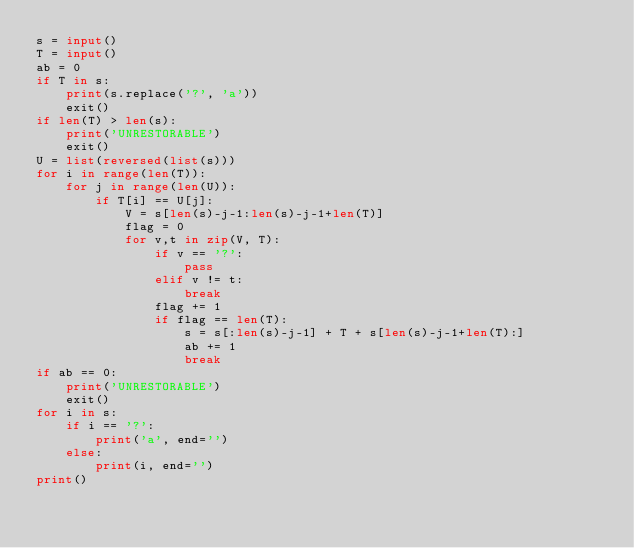Convert code to text. <code><loc_0><loc_0><loc_500><loc_500><_Python_>s = input()
T = input()
ab = 0
if T in s:
    print(s.replace('?', 'a'))
    exit()
if len(T) > len(s):
    print('UNRESTORABLE')
    exit()
U = list(reversed(list(s)))
for i in range(len(T)):
    for j in range(len(U)):
        if T[i] == U[j]:
            V = s[len(s)-j-1:len(s)-j-1+len(T)]
            flag = 0
            for v,t in zip(V, T):
                if v == '?':
                    pass
                elif v != t:
                    break
                flag += 1
                if flag == len(T):
                    s = s[:len(s)-j-1] + T + s[len(s)-j-1+len(T):]
                    ab += 1
                    break
if ab == 0:
    print('UNRESTORABLE')
    exit()
for i in s:
    if i == '?':
        print('a', end='')
    else:
        print(i, end='')
print()
</code> 